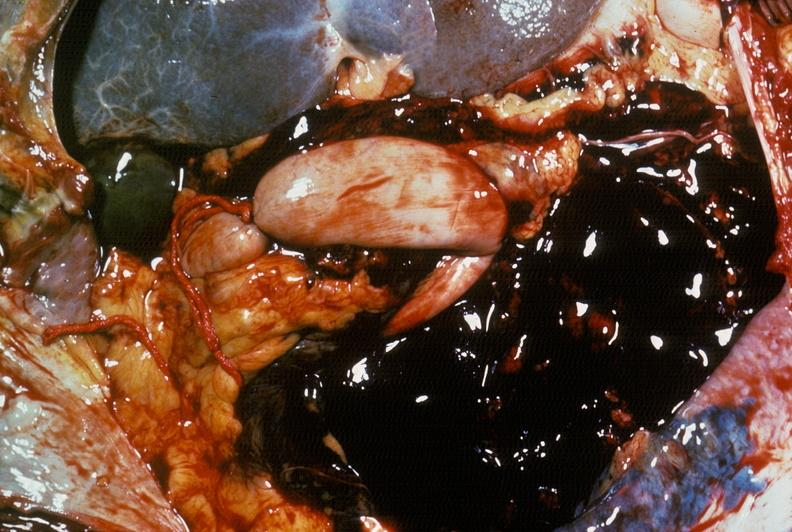does abdomen show hemorrhage secondary to ruptured aneurysm?
Answer the question using a single word or phrase. No 